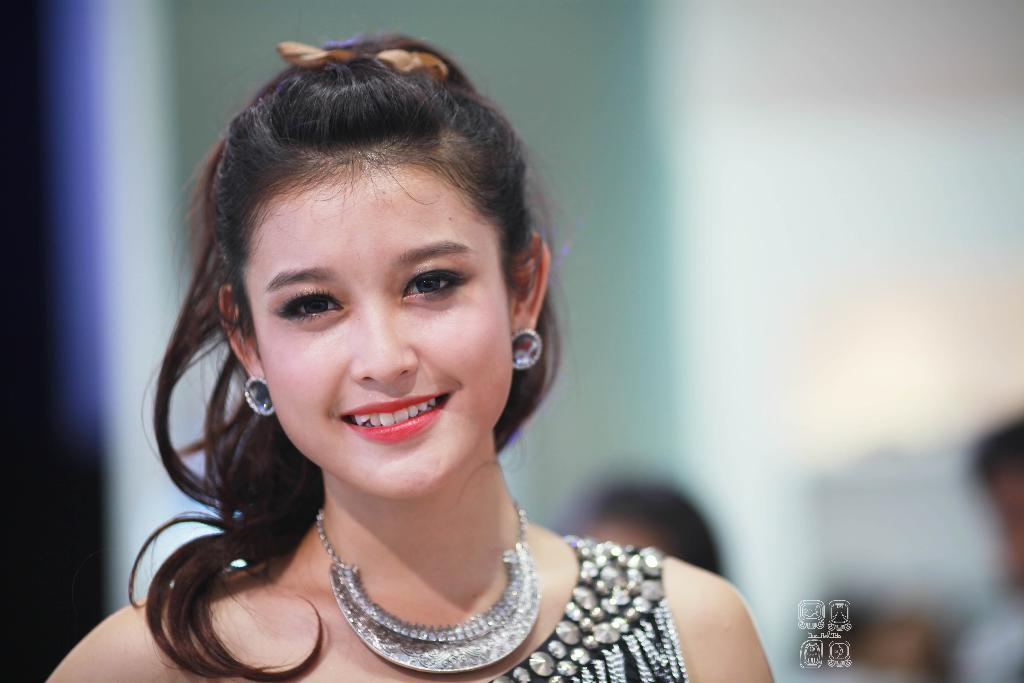Who is present in the image? There is a woman in the image. What is the woman's facial expression? The woman is smiling. In which direction is the woman looking? The woman is looking forward. Can you describe the background of the image? The background of the image is blurred. Is there any additional information or markings on the image? Yes, there is a watermark in the image. How many babies are sitting on the kettle in the image? There is no kettle or babies present in the image. What type of wing is visible on the woman in the image? There is no wing visible on the woman in the image. 